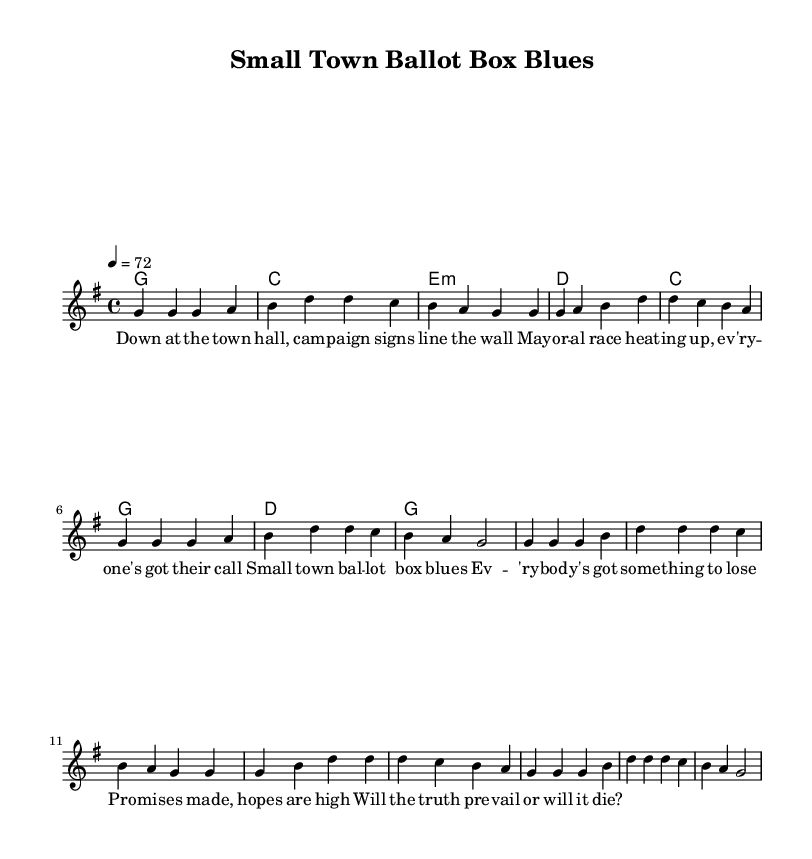What is the key signature of this music? The key signature is G major, which has one sharp (F#). This can be confirmed by the information in the global section of the code.
Answer: G major What is the time signature of this music? The time signature is 4/4, which means there are four beats per measure and a quarter note receives one beat. This is also stated in the global section of the code.
Answer: 4/4 What is the tempo marking for this piece? The tempo marking is 72 beats per minute, indicated by the tempo command in the global section of the music. This specifies the speed of the piece.
Answer: 72 What is the main theme of the lyrics? The main theme of the lyrics revolves around small-town politics and the local election atmosphere, discussing campaign signs and the heat of the mayoral race as portrayed in the verse.
Answer: Small-town politics Which chord is played in measure 2 of the verse? In measure 2 of the verse, the chord is C major, as indicated in the chord mode section of the code for that measure.
Answer: C What is the repetitive phrase in the chorus that emphasizes a central idea? The repetitive phrase in the chorus is "Small town ballot box blues," which summarizes the sentiment and local issues addressed throughout the song.
Answer: Small town ballot box blues 